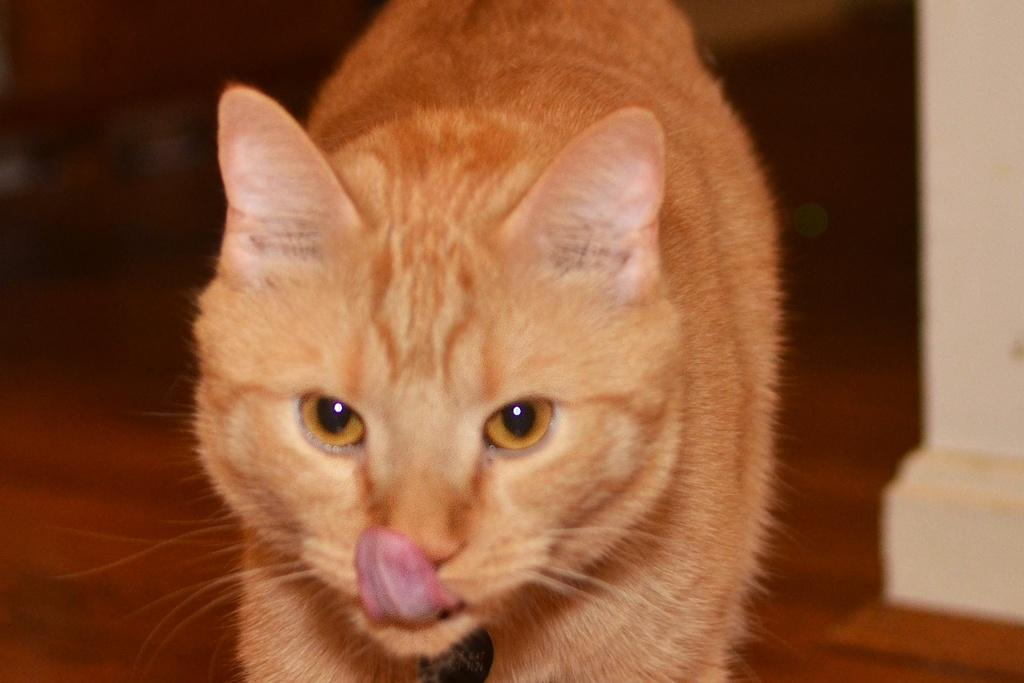What animal is in the picture? There is a cat in the picture. Where is the cat located in the picture? The cat is in the middle of the picture. What color is the cat? The cat is brown in color. How would you describe the background of the image? The background of the image is blurred. What type of rain is falling in the picture? There is no rain present in the picture; it only features a cat in the middle of the image. Can you hear the cat whistling in the picture? There is no whistling in the picture; it only features a brown cat in the middle of the image. 